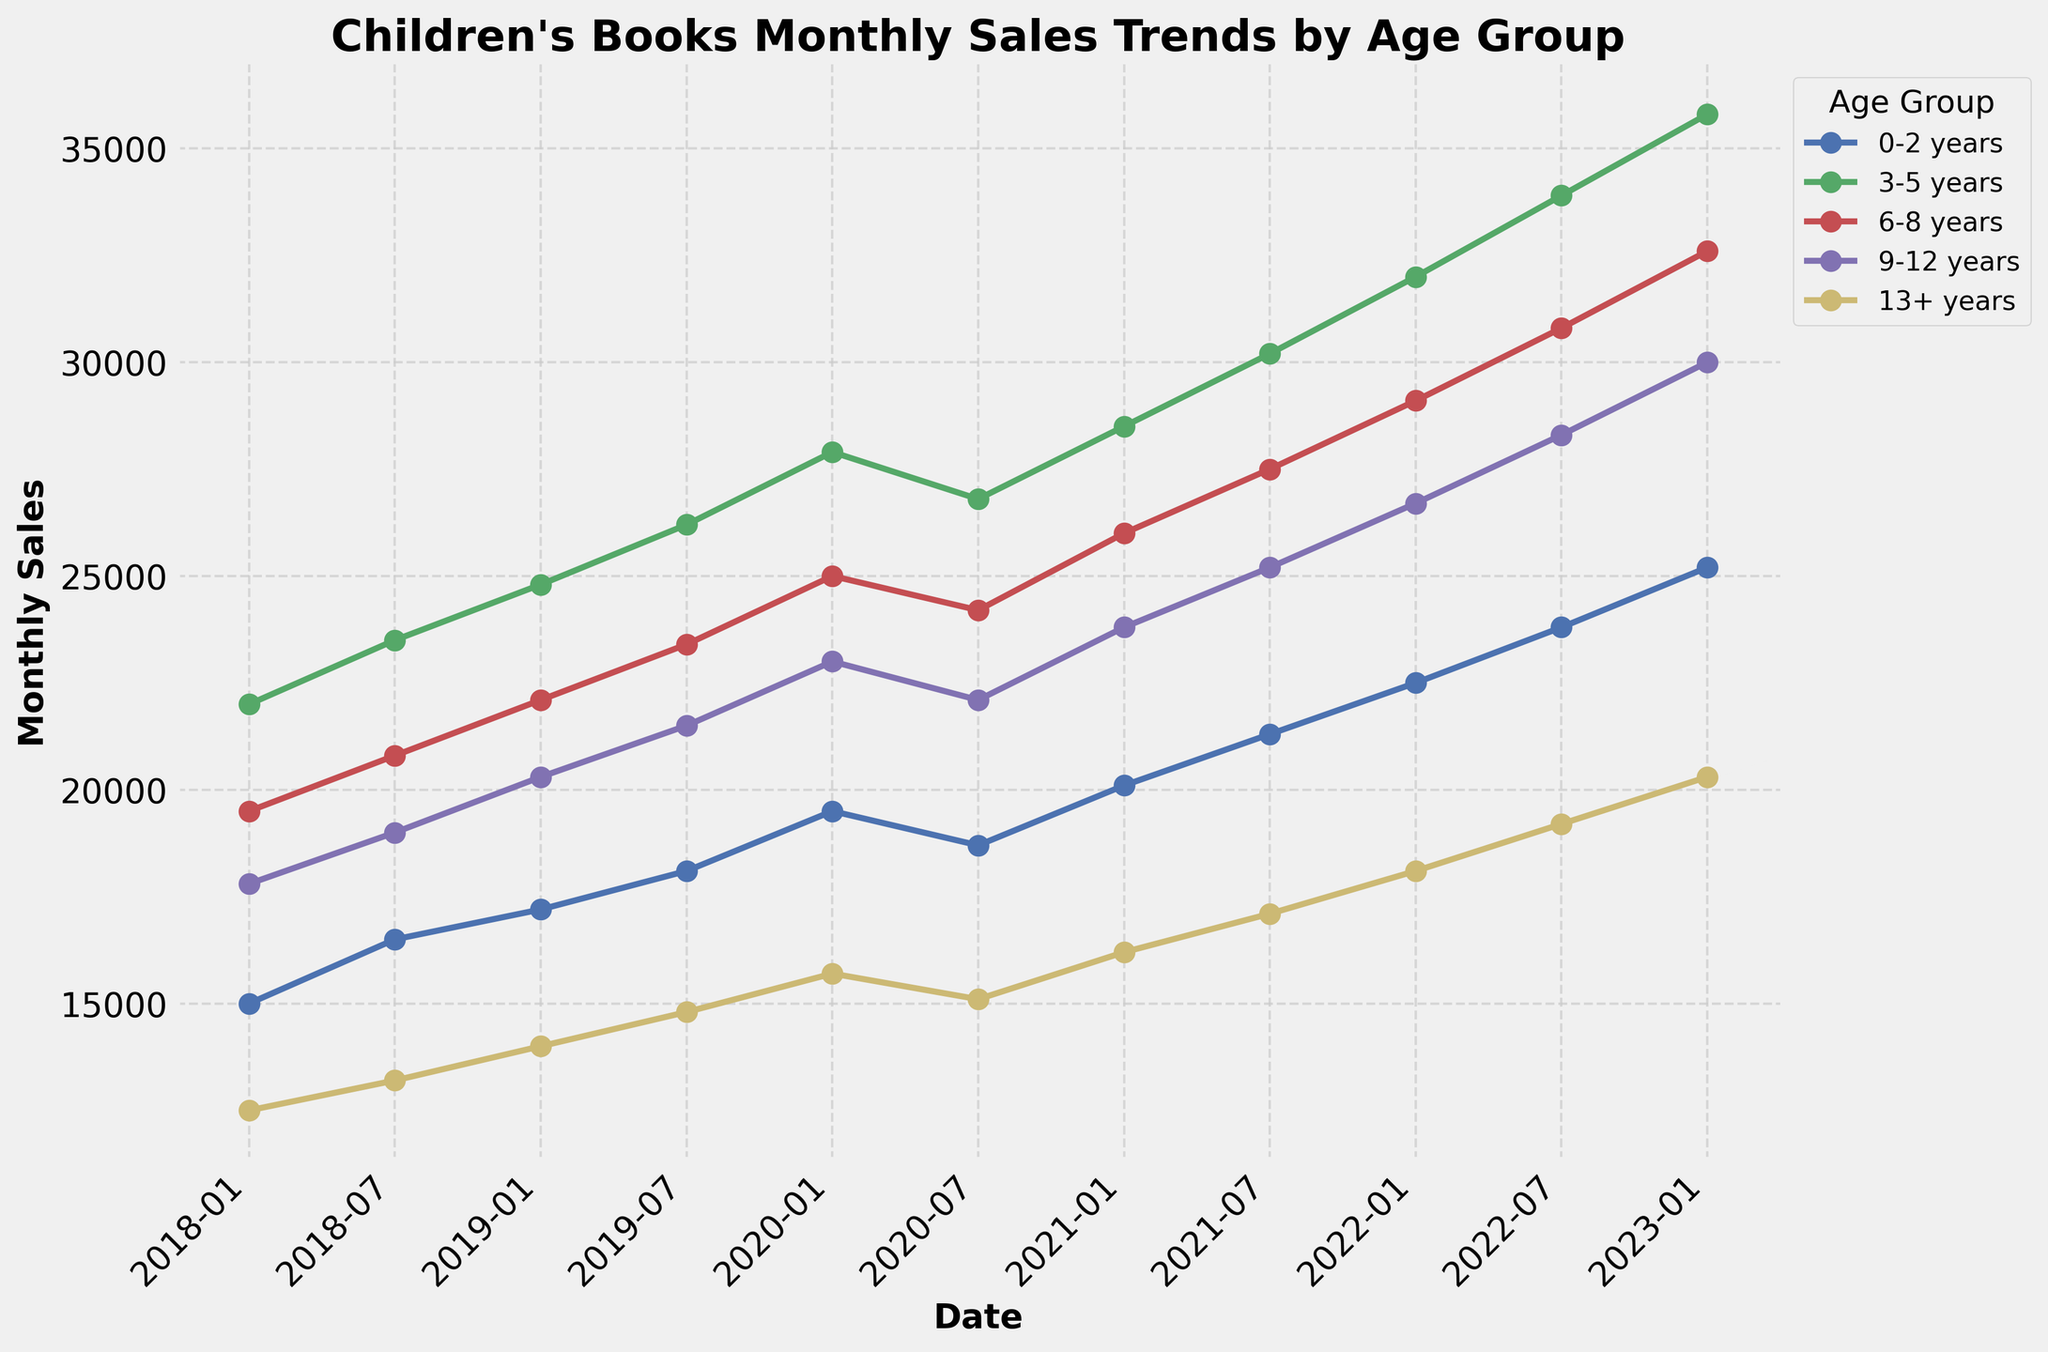What was the total sales in July 2022 for all age groups combined? Add up the sales figures for all age groups in July 2022: 23800 (0-2 years) + 33900 (3-5 years) + 30800 (6-8 years) + 28300 (9-12 years) + 19200 (13+ years) = 136000
Answer: 136000 Compared to January 2018, which age group showed the highest increase in sales by January 2023? Calculate the sales increase for each age group: 
0-2 years: 25200 - 15000 = 10200 
3-5 years: 35800 - 22000 = 13800 
6-8 years: 32600 - 19500 = 13100 
9-12 years: 30000 - 17800 = 12200 
13+ years: 20300 - 12500 = 7800 
3-5 years showed the highest increase (13800)
Answer: 3-5 years In 2020, which age group showed the most significant drop in sales between January and July? Calculate the sales difference for each age group between January and July of 2020:
0-2 years: 19500 - 18700 = 800 
3-5 years: 27900 - 26800 = 1100 
6-8 years: 25000 - 24200 = 800 
9-12 years: 23000 - 22100 = 900 
13+ years: 15700 - 15100 = 600 
The most significant drop is in the 3-5 years group (1100)
Answer: 3-5 years Which age group had the lowest sales in January 2018, and what was the amount? Compare sales for all age groups in January 2018: 
0-2 years: 15000 
3-5 years: 22000 
6-8 years: 19500 
9-12 years: 17800 
13+ years: 12500 
The lowest sales were for the 13+ years group with 12500
Answer: 13+ years, 12500 How did the sales trend for the 6-8 years group compare with the 9-12 years group between July 2021 and July 2022? Check sales for both groups at the mentioned points:
6-8 years: 
July 2021: 27500 
July 2022: 30800 
Increase: 30800 - 27500 = 3300 
9-12 years: 
July 2021: 25200 
July 2022: 28300 
Increase: 28300 - 25200 = 3100 
Both groups showed an upward trend with 6-8 years having a slightly larger increase by 200
Answer: 6-8 years increased by 3300, 9-12 years increased by 3100 In July 2021, which age group's sales were closest to 22000? Compare sales figures in July 2021:
0-2 years: 21300 
3-5 years: 30200 
6-8 years: 27500 
9-12 years: 25200 
13+ years: 17100 
The closest sales figure to 22000 is from the 0-2 years group with 21300
Answer: 0-2 years Which age group had the most consistent growth in sales over the past 5 years? By observing the trends:
0-2 years: Steady growth with no significant drops 
3-5 years: Steady growth with a minor decrease in 2020 
6-8 years: Steady growth with a minor decrease in 2020 
9-12 years: Steady growth with a minor decrease in 2020 
13+ years: Steady growth with a minor decrease in 2020 
0-2 years and 3-5 years show the most consistent growth, but 0-2 years had no significant drops
Answer: 0-2 years From July 2018 to January 2023, which age group's sales almost doubled? Compare July 2018 and January 2023 figures:
0-2 years: 16500 to 25200, not doubled 
3-5 years: 23500 to 35800, not doubled 
6-8 years: 20800 to 32600, almost doubled 
9-12 years: 19000 to 30000, almost doubled 
13+ years: 13200 to 20300, almost doubled 
6-8 years, 9-12 years, and 13+ years doubled or almost doubled, but only 6-8 years is closest to exactly doubling
Answer: 6-8 years 